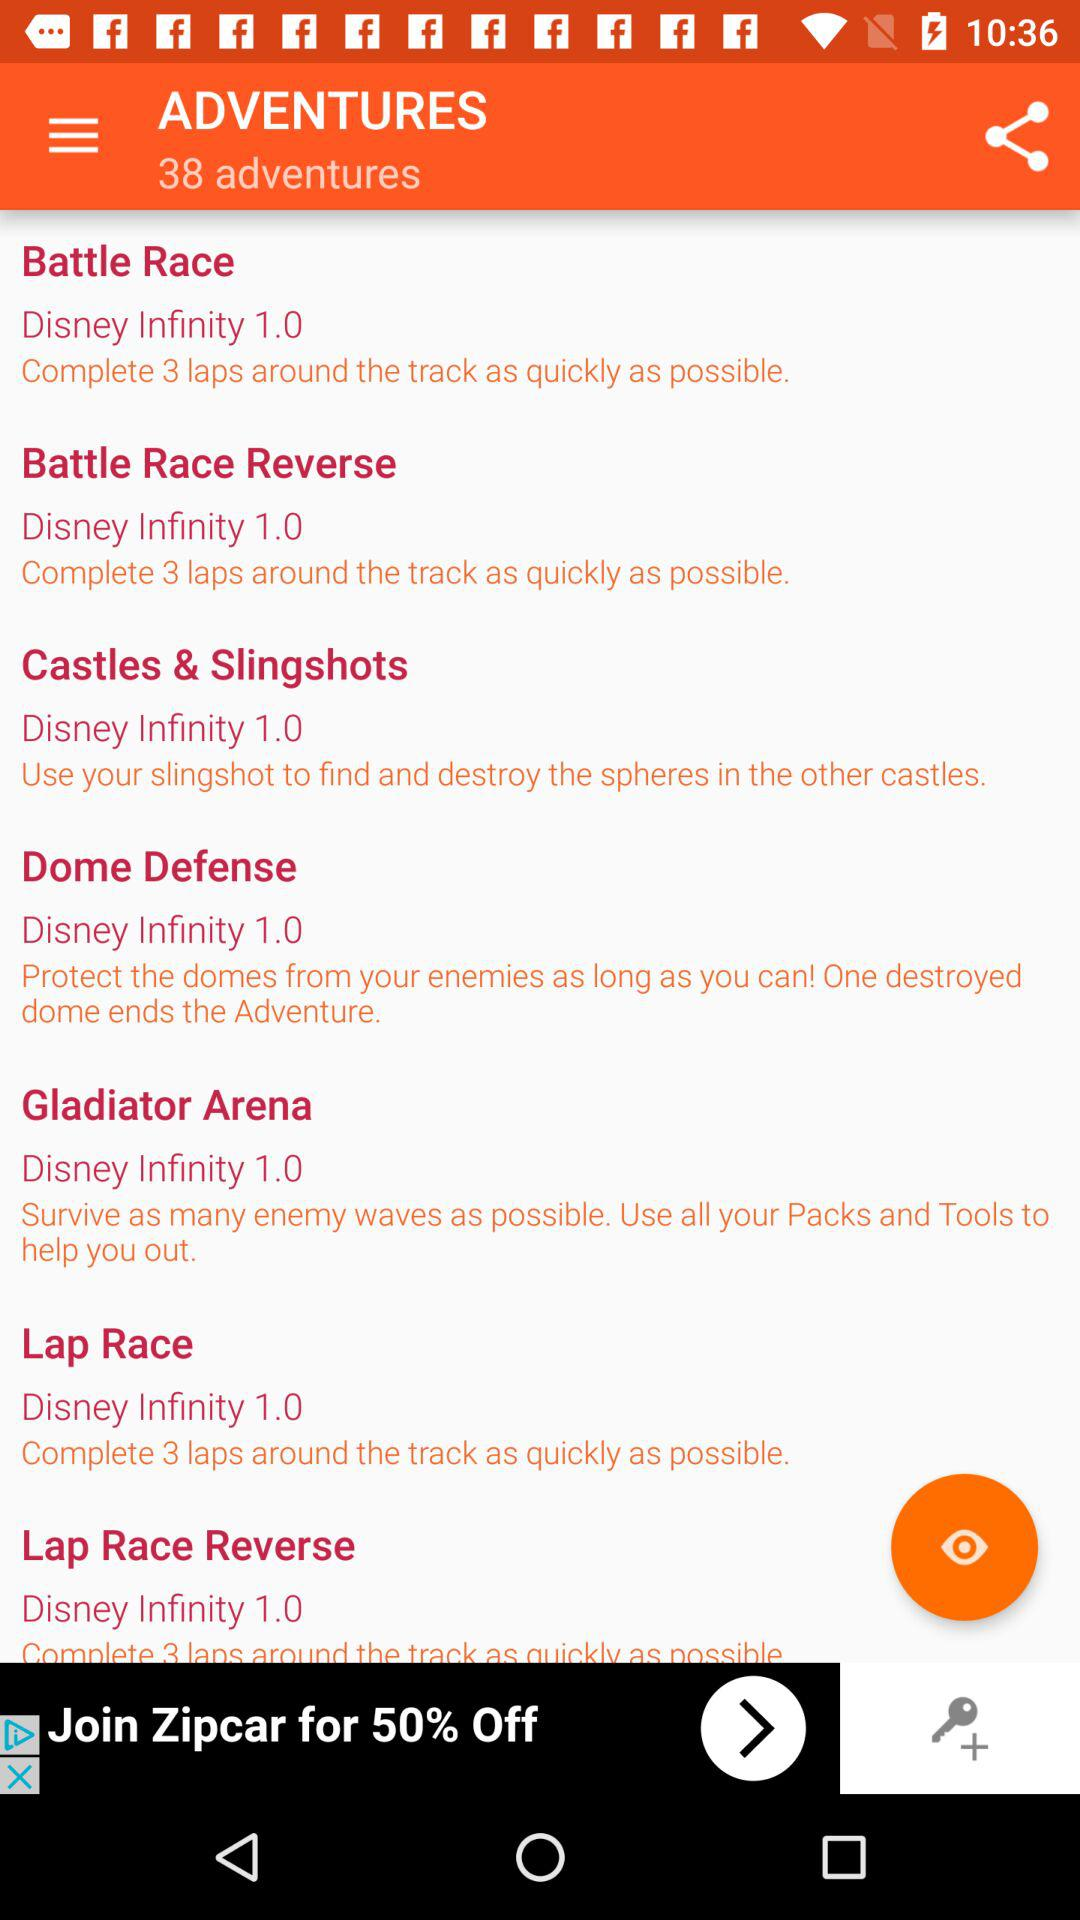What is the number of laps in the "Lap Race"? The number of laps in the "Lap Race" is 3. 